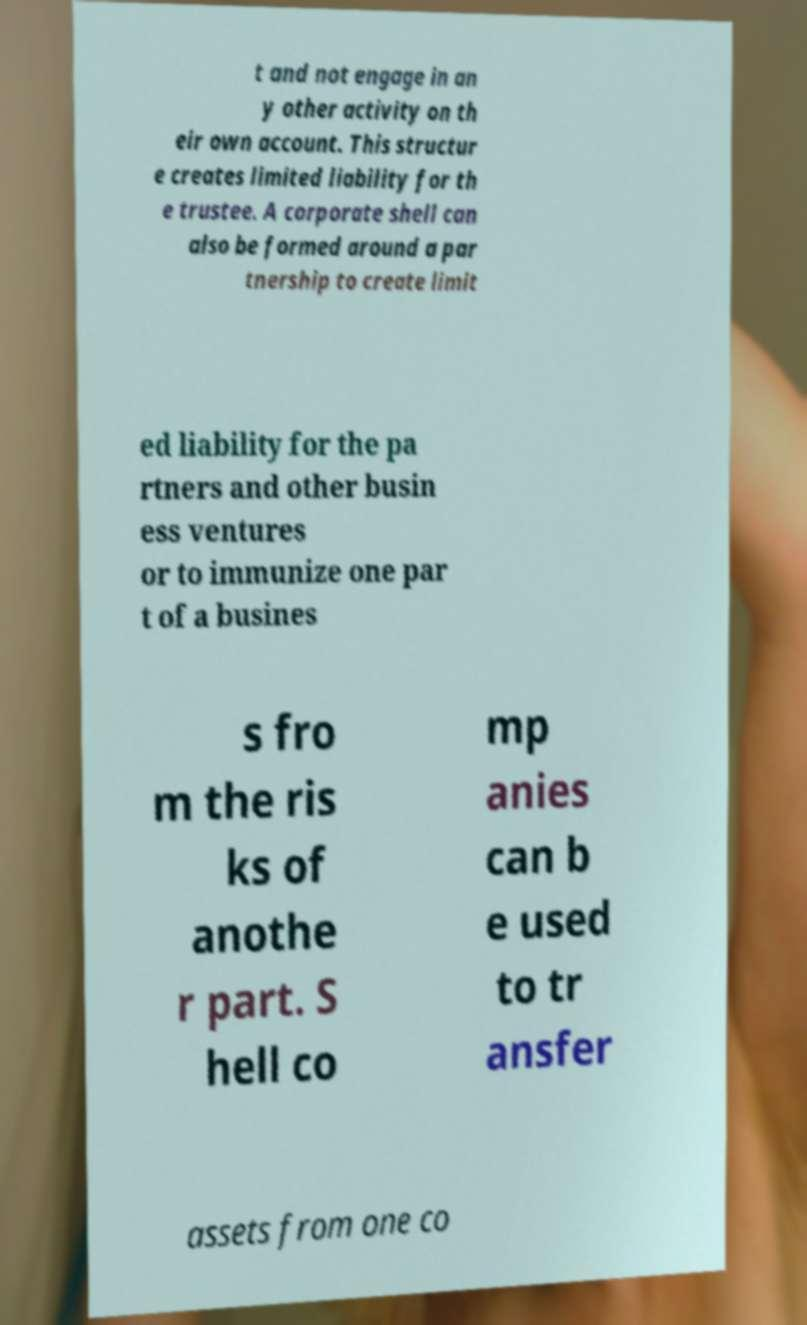Could you assist in decoding the text presented in this image and type it out clearly? t and not engage in an y other activity on th eir own account. This structur e creates limited liability for th e trustee. A corporate shell can also be formed around a par tnership to create limit ed liability for the pa rtners and other busin ess ventures or to immunize one par t of a busines s fro m the ris ks of anothe r part. S hell co mp anies can b e used to tr ansfer assets from one co 